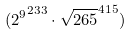Convert formula to latex. <formula><loc_0><loc_0><loc_500><loc_500>( { 2 ^ { 9 } } ^ { 2 3 3 } \cdot \sqrt { 2 6 5 } ^ { 4 1 5 } )</formula> 